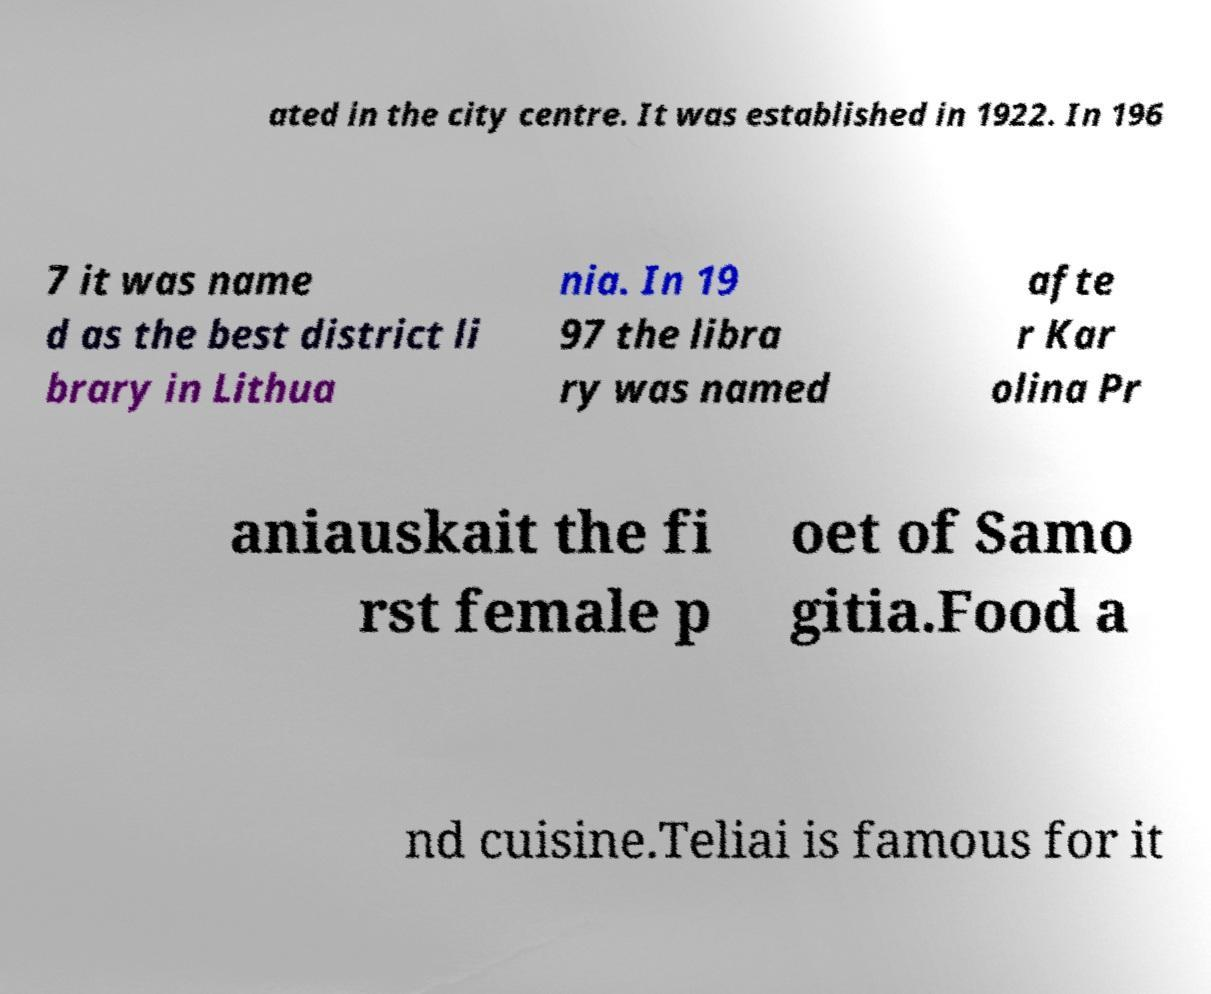Please identify and transcribe the text found in this image. ated in the city centre. It was established in 1922. In 196 7 it was name d as the best district li brary in Lithua nia. In 19 97 the libra ry was named afte r Kar olina Pr aniauskait the fi rst female p oet of Samo gitia.Food a nd cuisine.Teliai is famous for it 